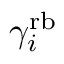<formula> <loc_0><loc_0><loc_500><loc_500>\gamma _ { i } ^ { r b }</formula> 